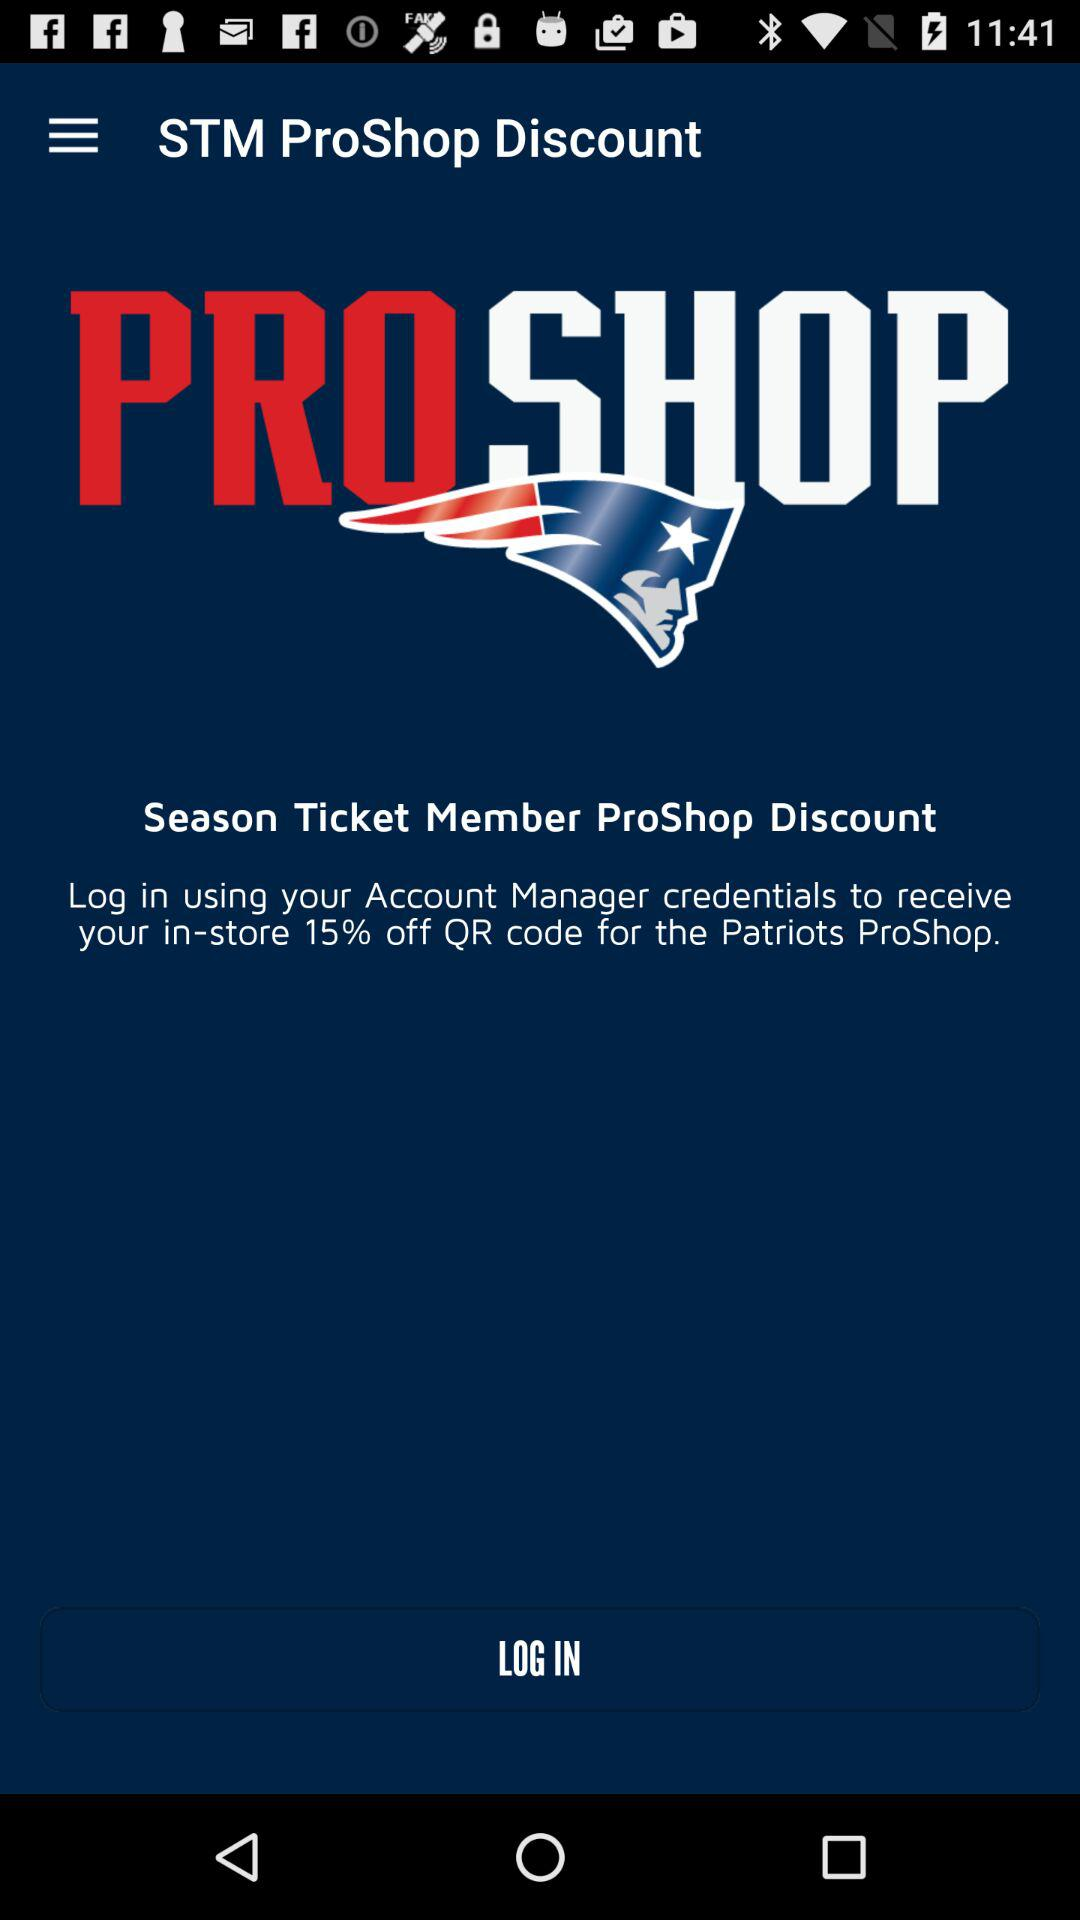What is the app name? The app name is "PROSHOP". 